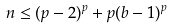Convert formula to latex. <formula><loc_0><loc_0><loc_500><loc_500>n \leq ( p - 2 ) ^ { p } + p ( b - 1 ) ^ { p }</formula> 